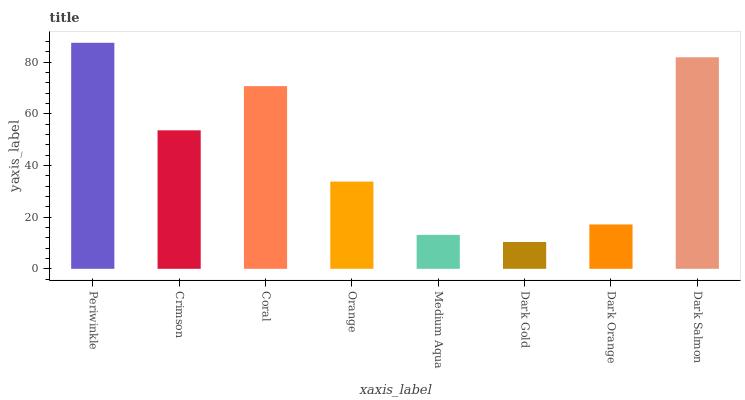Is Dark Gold the minimum?
Answer yes or no. Yes. Is Periwinkle the maximum?
Answer yes or no. Yes. Is Crimson the minimum?
Answer yes or no. No. Is Crimson the maximum?
Answer yes or no. No. Is Periwinkle greater than Crimson?
Answer yes or no. Yes. Is Crimson less than Periwinkle?
Answer yes or no. Yes. Is Crimson greater than Periwinkle?
Answer yes or no. No. Is Periwinkle less than Crimson?
Answer yes or no. No. Is Crimson the high median?
Answer yes or no. Yes. Is Orange the low median?
Answer yes or no. Yes. Is Dark Salmon the high median?
Answer yes or no. No. Is Periwinkle the low median?
Answer yes or no. No. 